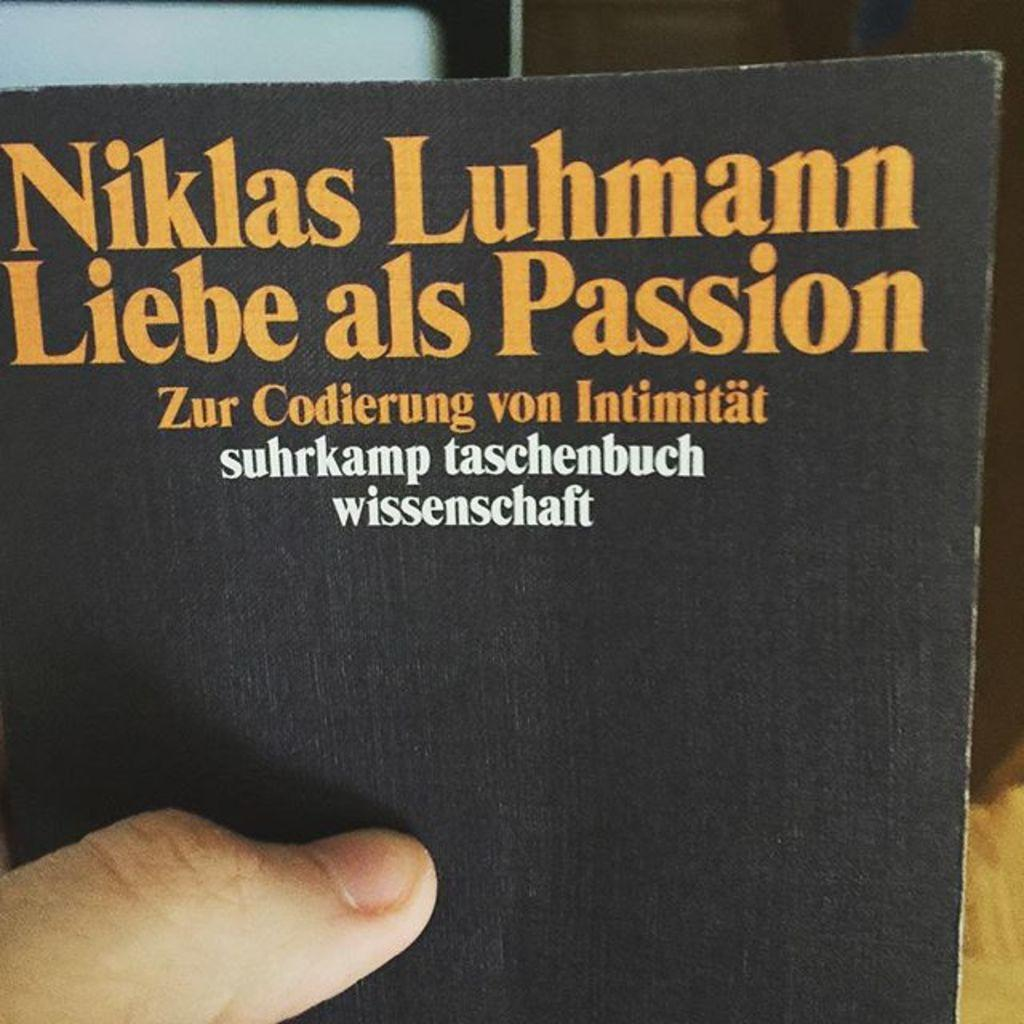<image>
Relay a brief, clear account of the picture shown. a man holding a cook called Niklas Luhmann Liebe Als Passion 